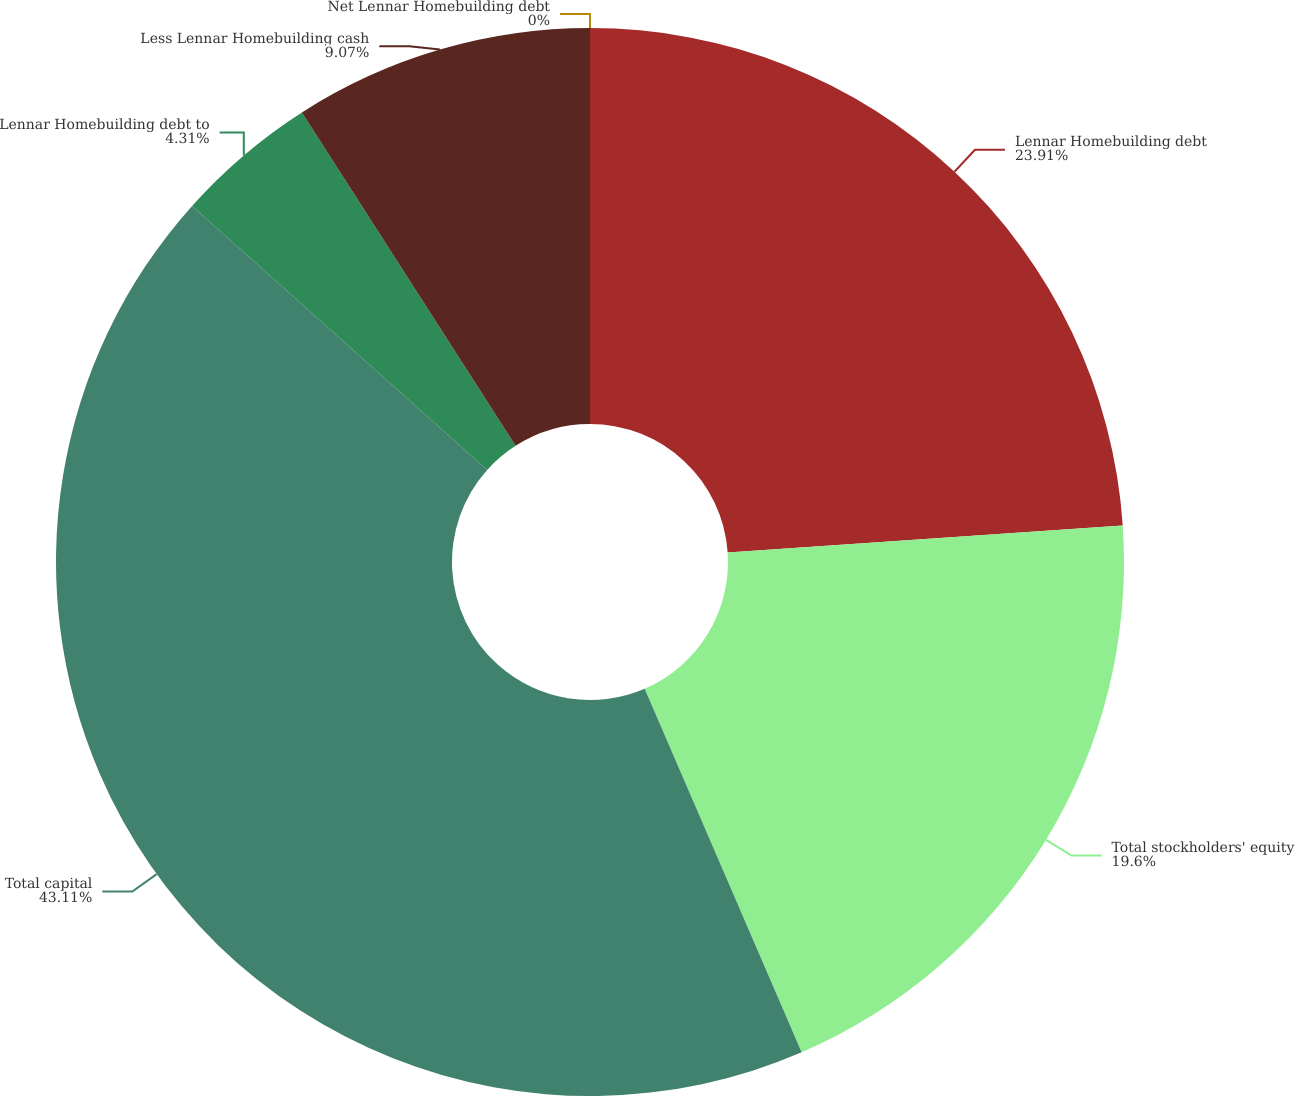Convert chart. <chart><loc_0><loc_0><loc_500><loc_500><pie_chart><fcel>Lennar Homebuilding debt<fcel>Total stockholders' equity<fcel>Total capital<fcel>Lennar Homebuilding debt to<fcel>Less Lennar Homebuilding cash<fcel>Net Lennar Homebuilding debt<nl><fcel>23.91%<fcel>19.6%<fcel>43.1%<fcel>4.31%<fcel>9.07%<fcel>0.0%<nl></chart> 